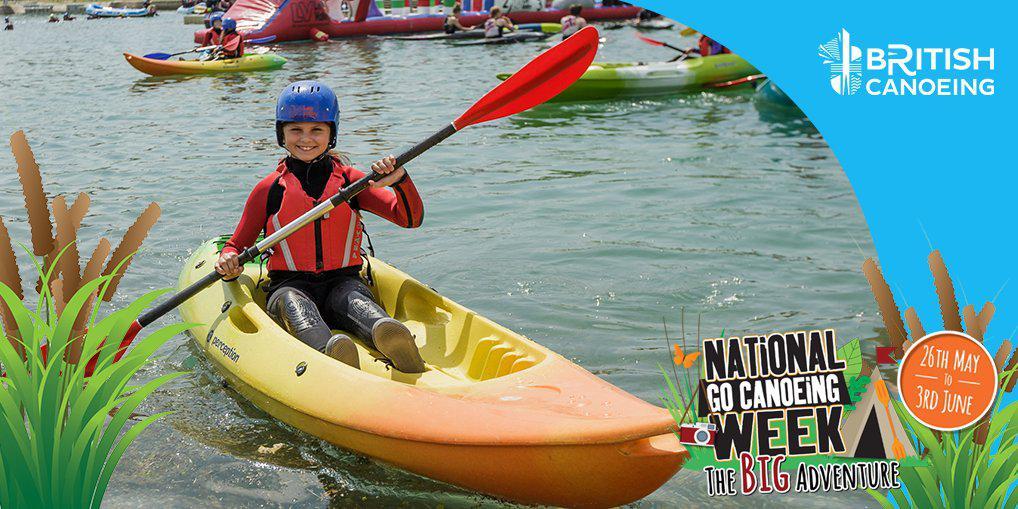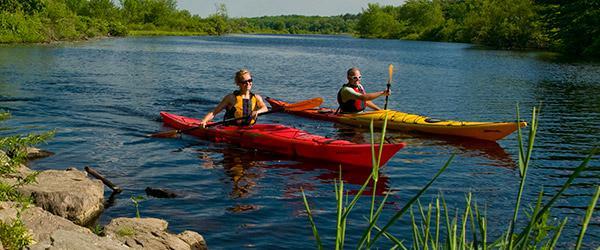The first image is the image on the left, the second image is the image on the right. Assess this claim about the two images: "Each image includes at least one person in a canoe on water, with the boat aimed forward.". Correct or not? Answer yes or no. Yes. 